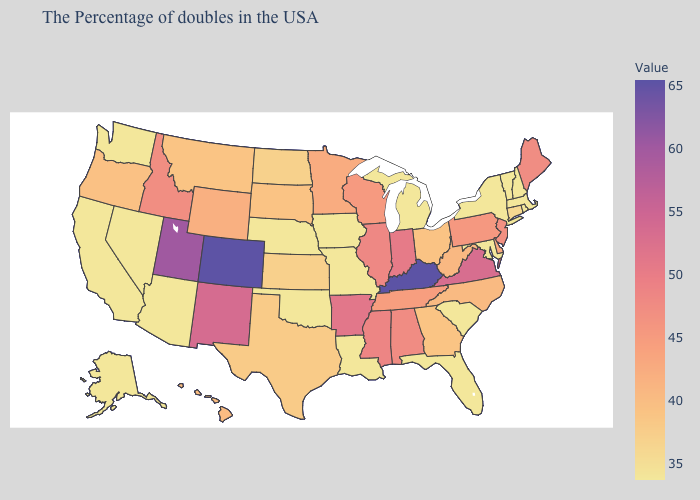Does the map have missing data?
Quick response, please. No. Among the states that border Tennessee , does Virginia have the lowest value?
Keep it brief. No. 